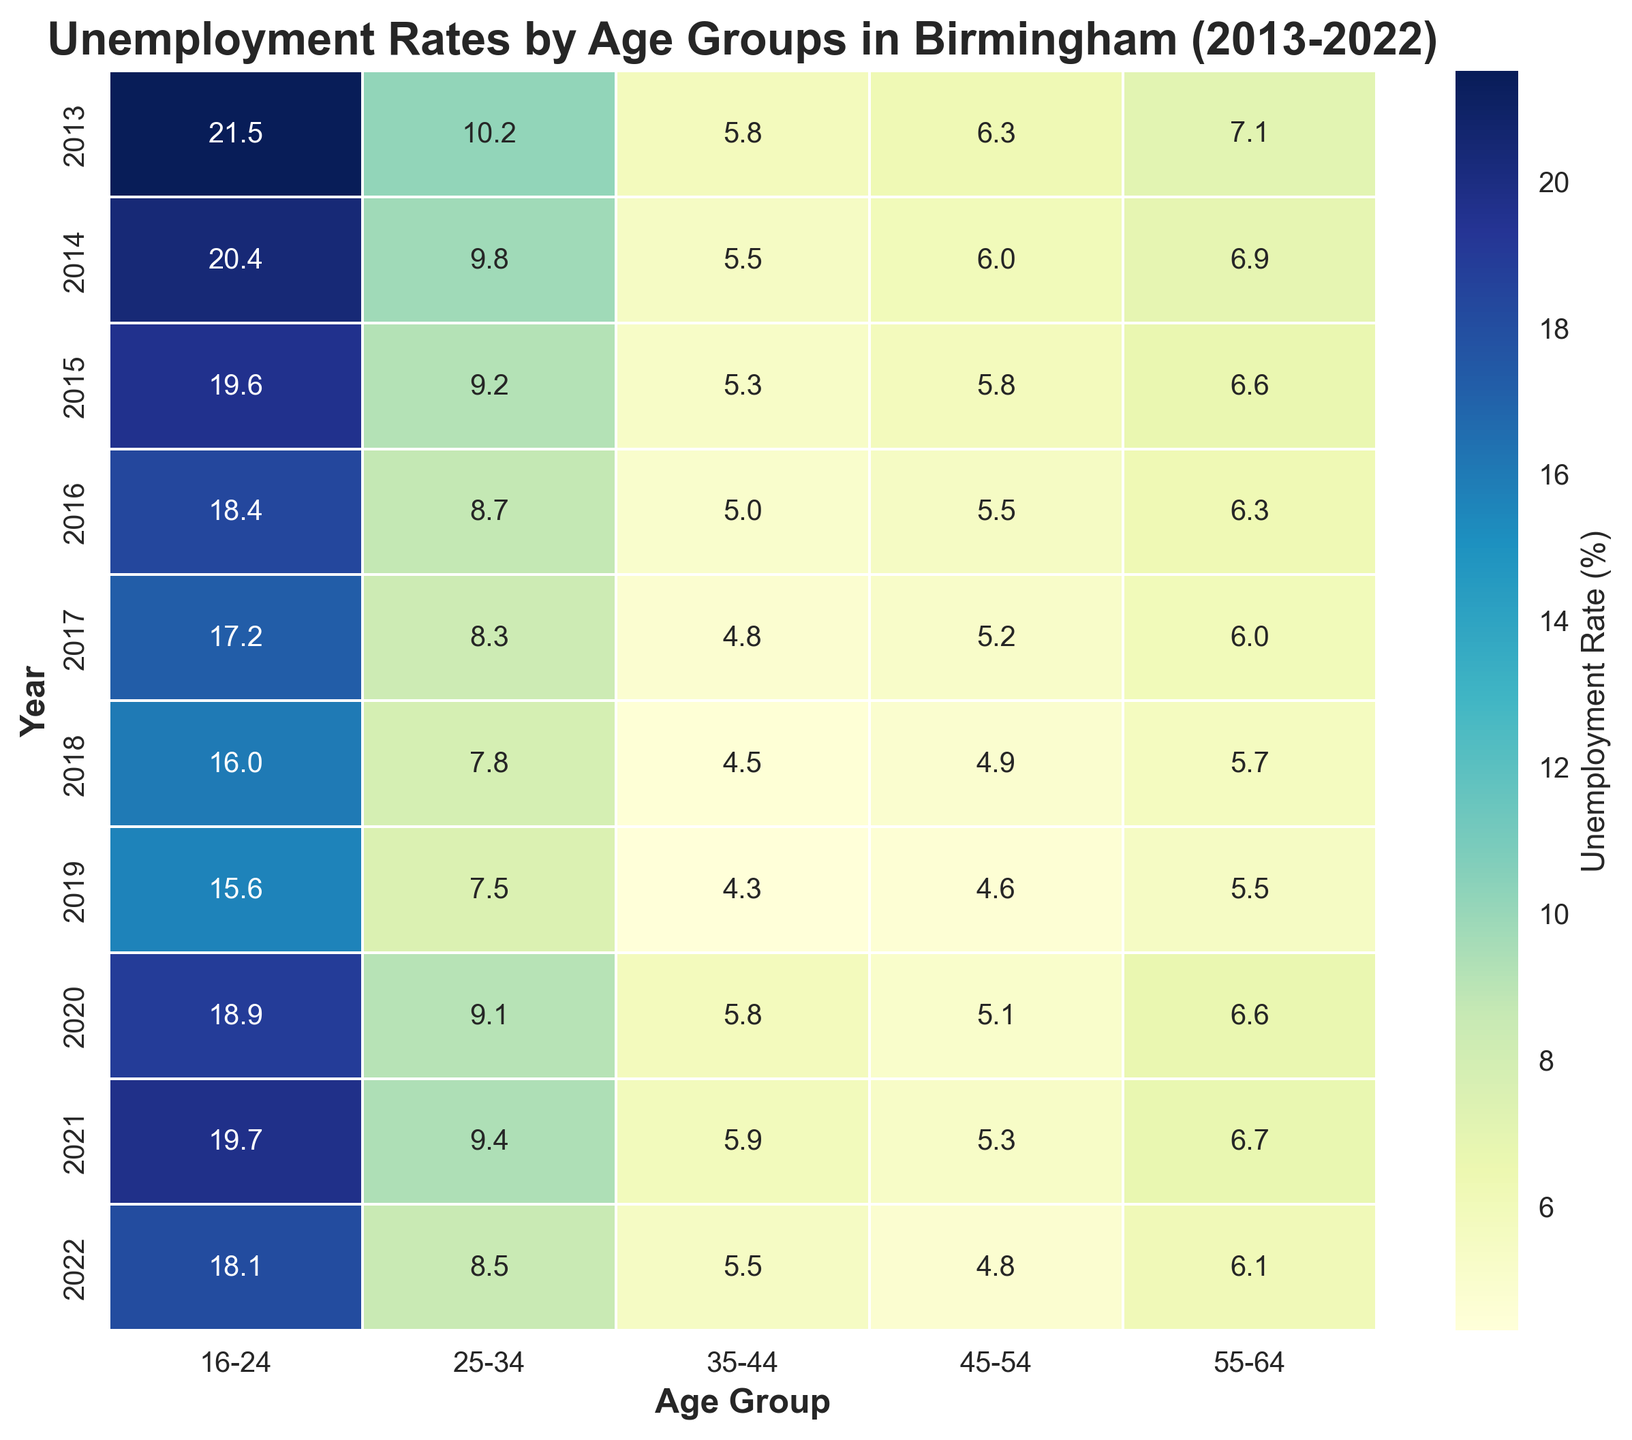Which age group experienced the highest unemployment rate in 2013? By looking at the cells for the year 2013 in the heatmap, the darkest shade represents the highest unemployment rate which is 21.5% for the age group 16-24.
Answer: 16-24 How did the unemployment rate for the age group 55-64 change from 2013 to 2022? Finding the values for 55-64 for 2013 and 2022 and comparing them, in 2013 it is 7.1% and in 2022 it is 6.1%.
Answer: It decreased Which year saw the lowest unemployment rate for the age group 35-44? By identifying the lightest cell in the 35-44 column, the lowest value is 4.3% which occurs in 2019.
Answer: 2019 What's the average unemployment rate for the age group 25-34 across the years 2013, 2017, and 2022? Summing the rates for 25-34 for the years 2013, 2017, and 2022 (10.2 + 8.3 + 8.5) and then dividing by 3, the average is approximately 9.0%.
Answer: 9.0% In which year did the unemployment rate for the age group 16-24 see the greatest increase compared to the previous year? Comparing subsequent years for the 16-24 group, the rate increased from 15.6% in 2019 to 18.9% in 2020, which is the largest increase of 3.3%.
Answer: 2020 Which age group consistently had the lowest unemployment rate over the decade? Looking at the lower rates across all the age groups, the age group 35-44 consistently has the lowest rates.
Answer: 35-44 Between 2013 and 2022, what is the decrease in the unemployment rate for the age group 45-54? Subtracting the unemployment rate for 45-54 in 2022 from that in 2013 (6.3% - 4.8%), the decrease is 1.5%.
Answer: 1.5% How does the unemployment rate of the 25-34 age group in 2015 compare to that in 2016? By comparing the two values, 9.2% in 2015 and 8.7% in 2016, the rate decreased in 2016.
Answer: 2016 is lower Which age group shows the most significant improvement in unemployment rates between 2017 and 2021? Calculating the difference between 2017 and 2021's unemployment rates for each age group, the most significant drop is for 16-24 (17.2% to 19.7% would be increased, so the next likely significant change would be less for 35-44 from 4.8% to 5.9%).
Answer: No significant change detected 